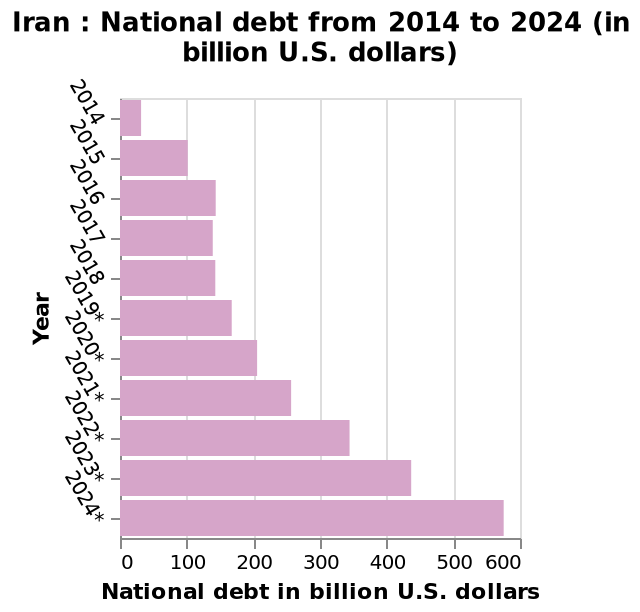<image>
please describe the details of the chart Iran : National debt from 2014 to 2024 (in billion U.S. dollars) is a bar plot. The y-axis plots Year while the x-axis plots National debt in billion U.S. dollars. What is being plotted on the x-axis of the bar plot?  The x-axis plots the National debt in billion U.S. dollars. 